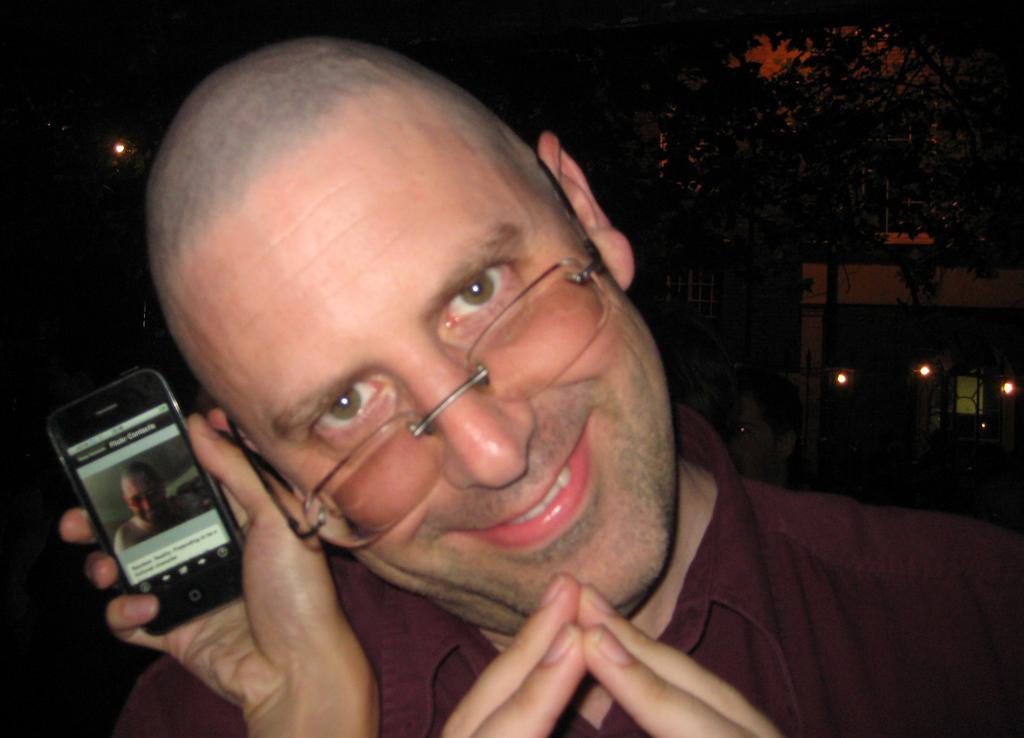Describe this image in one or two sentences. In this image in the middle, there is a man. He wears a shirt, he is smiling. On the left there is a person holding a mobile. In the background there are trees, buildings and lights. 